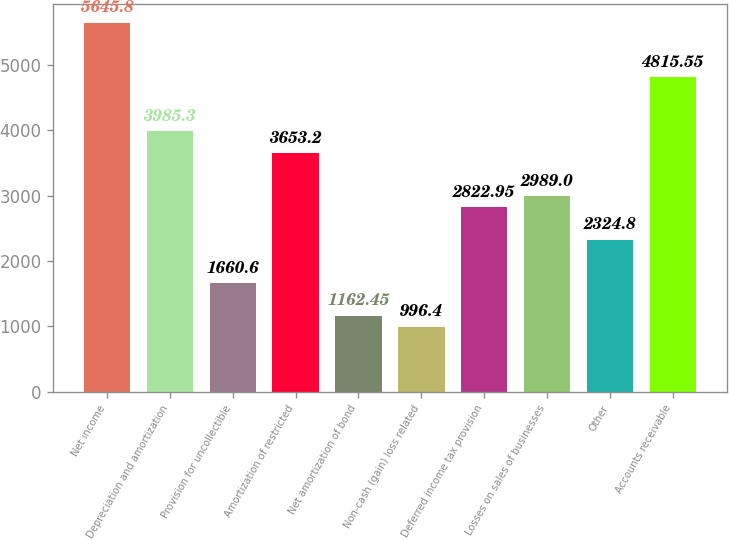<chart> <loc_0><loc_0><loc_500><loc_500><bar_chart><fcel>Net income<fcel>Depreciation and amortization<fcel>Provision for uncollectible<fcel>Amortization of restricted<fcel>Net amortization of bond<fcel>Non-cash (gain) loss related<fcel>Deferred income tax provision<fcel>Losses on sales of businesses<fcel>Other<fcel>Accounts receivable<nl><fcel>5645.8<fcel>3985.3<fcel>1660.6<fcel>3653.2<fcel>1162.45<fcel>996.4<fcel>2822.95<fcel>2989<fcel>2324.8<fcel>4815.55<nl></chart> 